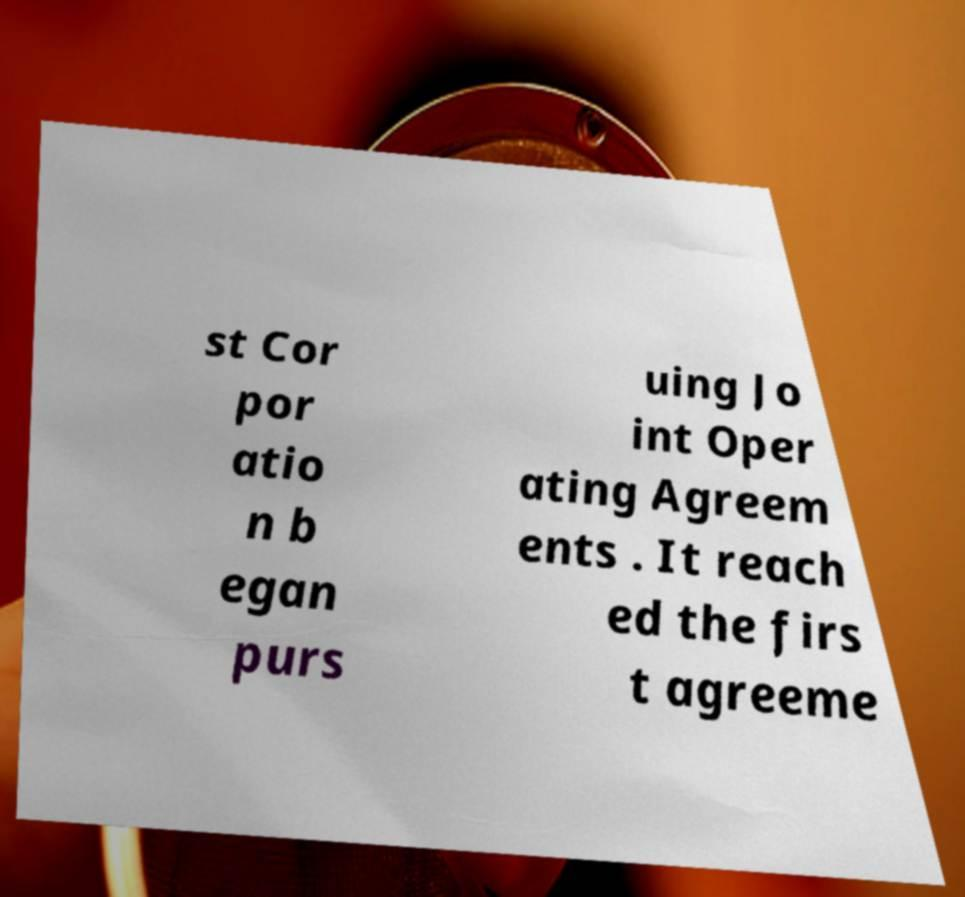For documentation purposes, I need the text within this image transcribed. Could you provide that? st Cor por atio n b egan purs uing Jo int Oper ating Agreem ents . It reach ed the firs t agreeme 